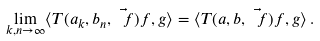Convert formula to latex. <formula><loc_0><loc_0><loc_500><loc_500>\lim _ { k , n \to \infty } \langle T ( a _ { k } , b _ { n } , \vec { \ f } ) f , g \rangle = \langle T ( a , b , \vec { \ f } ) f , g \rangle \, .</formula> 